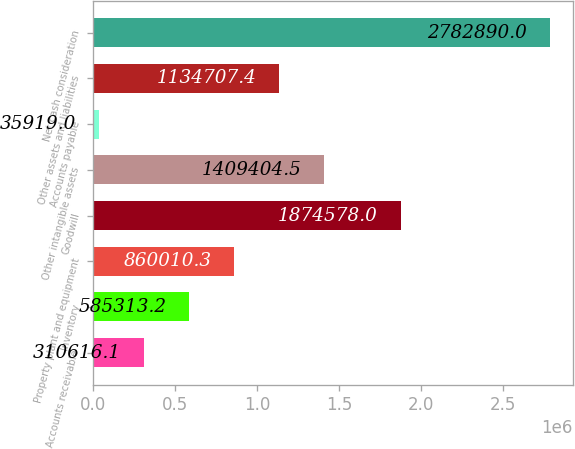Convert chart to OTSL. <chart><loc_0><loc_0><loc_500><loc_500><bar_chart><fcel>Accounts receivable<fcel>Inventory<fcel>Property plant and equipment<fcel>Goodwill<fcel>Other intangible assets<fcel>Accounts payable<fcel>Other assets and liabilities<fcel>Net cash consideration<nl><fcel>310616<fcel>585313<fcel>860010<fcel>1.87458e+06<fcel>1.4094e+06<fcel>35919<fcel>1.13471e+06<fcel>2.78289e+06<nl></chart> 